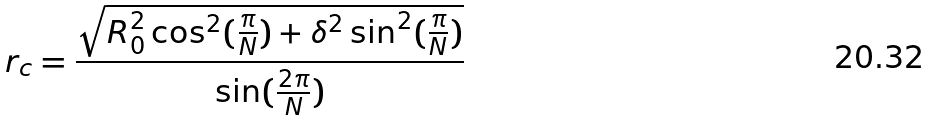<formula> <loc_0><loc_0><loc_500><loc_500>r _ { c } = \frac { \sqrt { R _ { 0 } ^ { 2 } \cos ^ { 2 } ( \frac { \pi } { N } ) + \delta ^ { 2 } \sin ^ { 2 } ( \frac { \pi } { N } ) } } { \sin ( \frac { 2 \pi } { N } ) }</formula> 